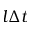Convert formula to latex. <formula><loc_0><loc_0><loc_500><loc_500>l \Delta t</formula> 